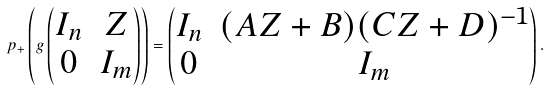<formula> <loc_0><loc_0><loc_500><loc_500>p _ { + } \left ( g \begin{pmatrix} I _ { n } & Z \\ 0 & I _ { m } \end{pmatrix} \right ) = \begin{pmatrix} I _ { n } & ( A Z + B ) ( C Z + D ) ^ { - 1 } \\ 0 & I _ { m } \end{pmatrix} .</formula> 